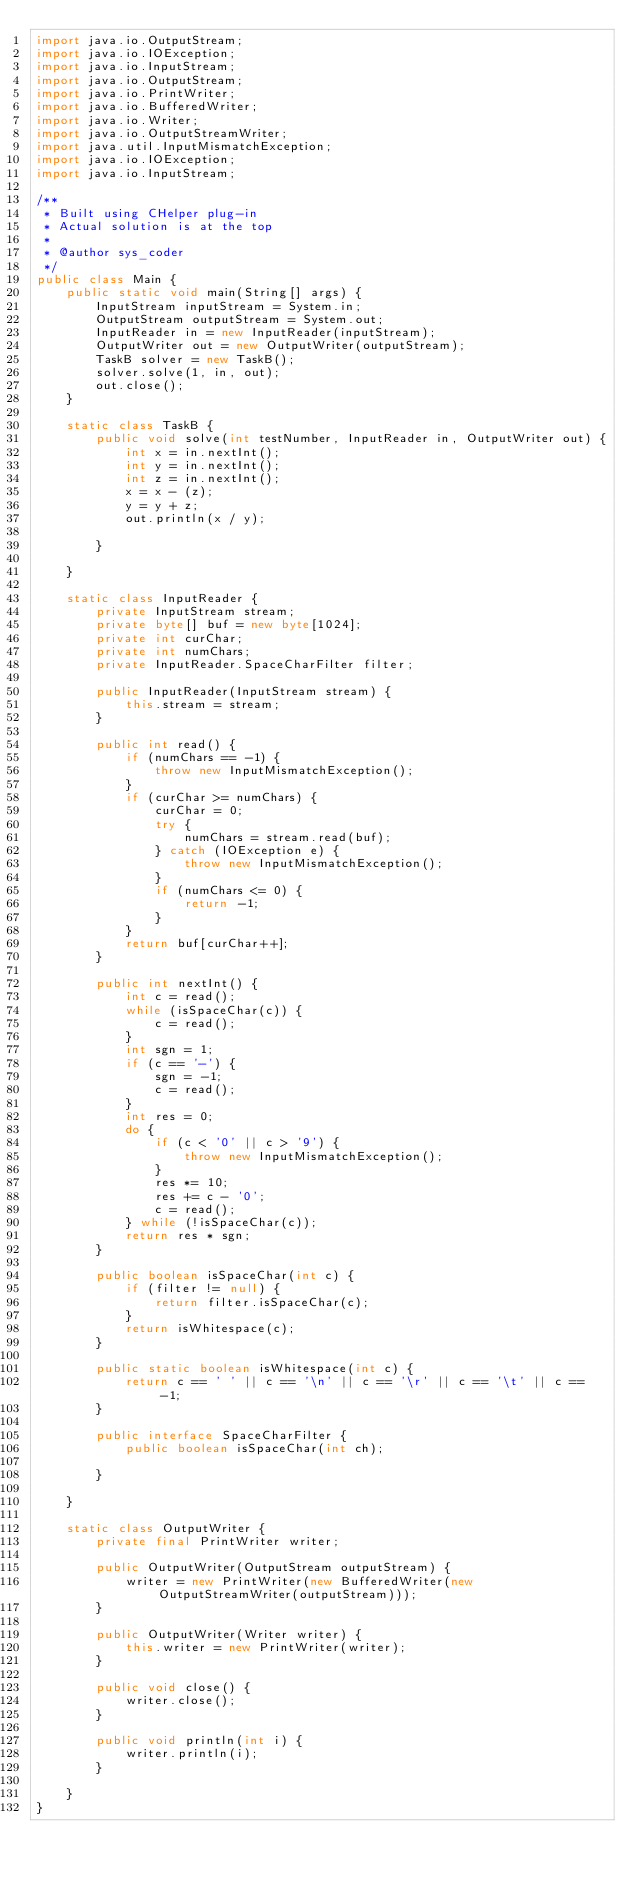Convert code to text. <code><loc_0><loc_0><loc_500><loc_500><_Java_>import java.io.OutputStream;
import java.io.IOException;
import java.io.InputStream;
import java.io.OutputStream;
import java.io.PrintWriter;
import java.io.BufferedWriter;
import java.io.Writer;
import java.io.OutputStreamWriter;
import java.util.InputMismatchException;
import java.io.IOException;
import java.io.InputStream;

/**
 * Built using CHelper plug-in
 * Actual solution is at the top
 *
 * @author sys_coder
 */
public class Main {
    public static void main(String[] args) {
        InputStream inputStream = System.in;
        OutputStream outputStream = System.out;
        InputReader in = new InputReader(inputStream);
        OutputWriter out = new OutputWriter(outputStream);
        TaskB solver = new TaskB();
        solver.solve(1, in, out);
        out.close();
    }

    static class TaskB {
        public void solve(int testNumber, InputReader in, OutputWriter out) {
            int x = in.nextInt();
            int y = in.nextInt();
            int z = in.nextInt();
            x = x - (z);
            y = y + z;
            out.println(x / y);

        }

    }

    static class InputReader {
        private InputStream stream;
        private byte[] buf = new byte[1024];
        private int curChar;
        private int numChars;
        private InputReader.SpaceCharFilter filter;

        public InputReader(InputStream stream) {
            this.stream = stream;
        }

        public int read() {
            if (numChars == -1) {
                throw new InputMismatchException();
            }
            if (curChar >= numChars) {
                curChar = 0;
                try {
                    numChars = stream.read(buf);
                } catch (IOException e) {
                    throw new InputMismatchException();
                }
                if (numChars <= 0) {
                    return -1;
                }
            }
            return buf[curChar++];
        }

        public int nextInt() {
            int c = read();
            while (isSpaceChar(c)) {
                c = read();
            }
            int sgn = 1;
            if (c == '-') {
                sgn = -1;
                c = read();
            }
            int res = 0;
            do {
                if (c < '0' || c > '9') {
                    throw new InputMismatchException();
                }
                res *= 10;
                res += c - '0';
                c = read();
            } while (!isSpaceChar(c));
            return res * sgn;
        }

        public boolean isSpaceChar(int c) {
            if (filter != null) {
                return filter.isSpaceChar(c);
            }
            return isWhitespace(c);
        }

        public static boolean isWhitespace(int c) {
            return c == ' ' || c == '\n' || c == '\r' || c == '\t' || c == -1;
        }

        public interface SpaceCharFilter {
            public boolean isSpaceChar(int ch);

        }

    }

    static class OutputWriter {
        private final PrintWriter writer;

        public OutputWriter(OutputStream outputStream) {
            writer = new PrintWriter(new BufferedWriter(new OutputStreamWriter(outputStream)));
        }

        public OutputWriter(Writer writer) {
            this.writer = new PrintWriter(writer);
        }

        public void close() {
            writer.close();
        }

        public void println(int i) {
            writer.println(i);
        }

    }
}

</code> 